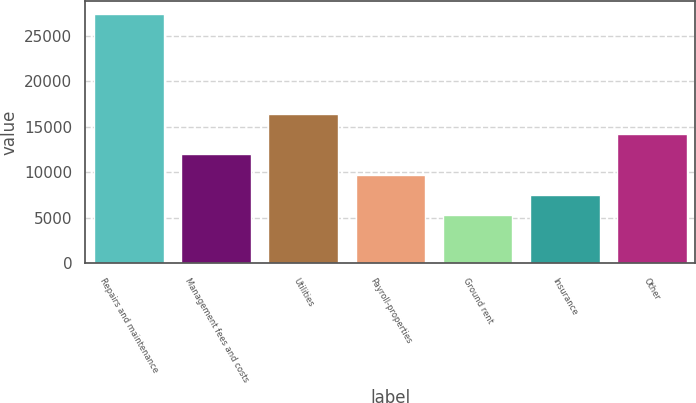Convert chart to OTSL. <chart><loc_0><loc_0><loc_500><loc_500><bar_chart><fcel>Repairs and maintenance<fcel>Management fees and costs<fcel>Utilities<fcel>Payroll-properties<fcel>Ground rent<fcel>Insurance<fcel>Other<nl><fcel>27410<fcel>11976<fcel>16401.8<fcel>9706.8<fcel>5281<fcel>7493.9<fcel>14188.9<nl></chart> 